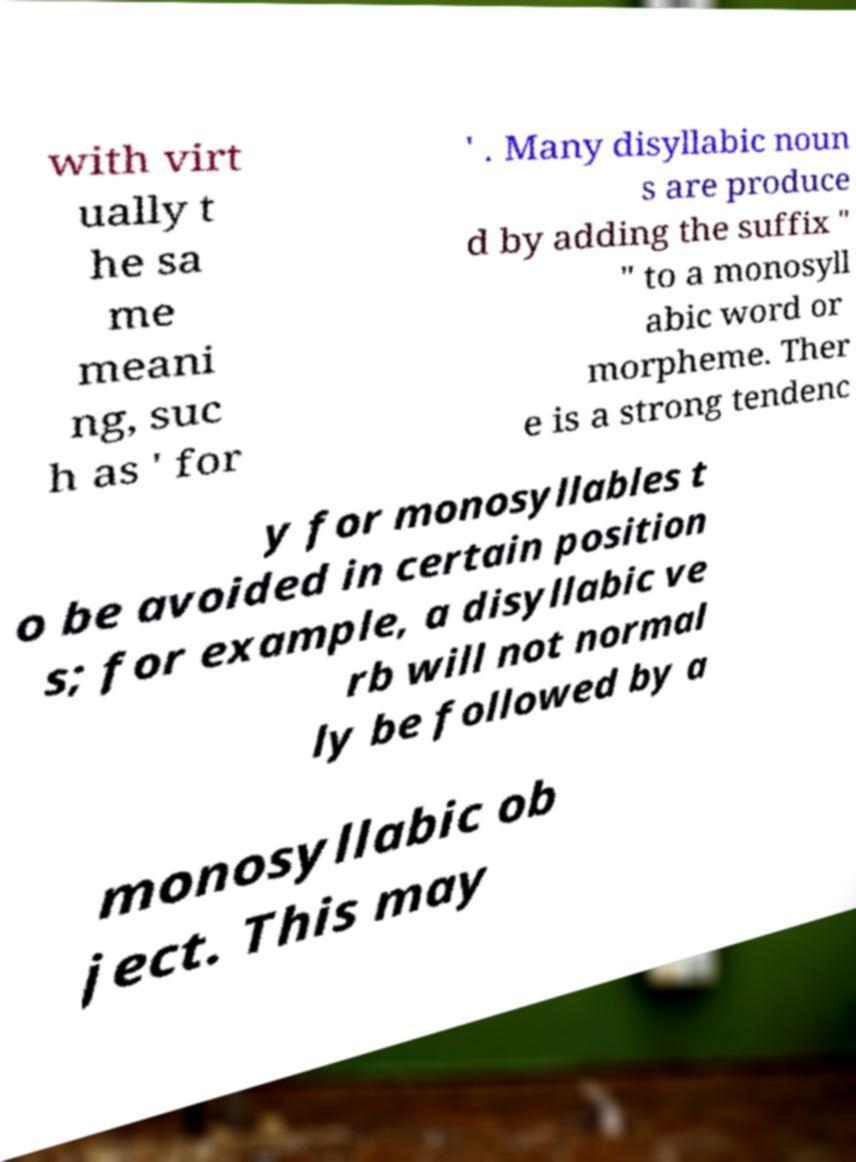Could you extract and type out the text from this image? with virt ually t he sa me meani ng, suc h as ' for ' . Many disyllabic noun s are produce d by adding the suffix " " to a monosyll abic word or morpheme. Ther e is a strong tendenc y for monosyllables t o be avoided in certain position s; for example, a disyllabic ve rb will not normal ly be followed by a monosyllabic ob ject. This may 